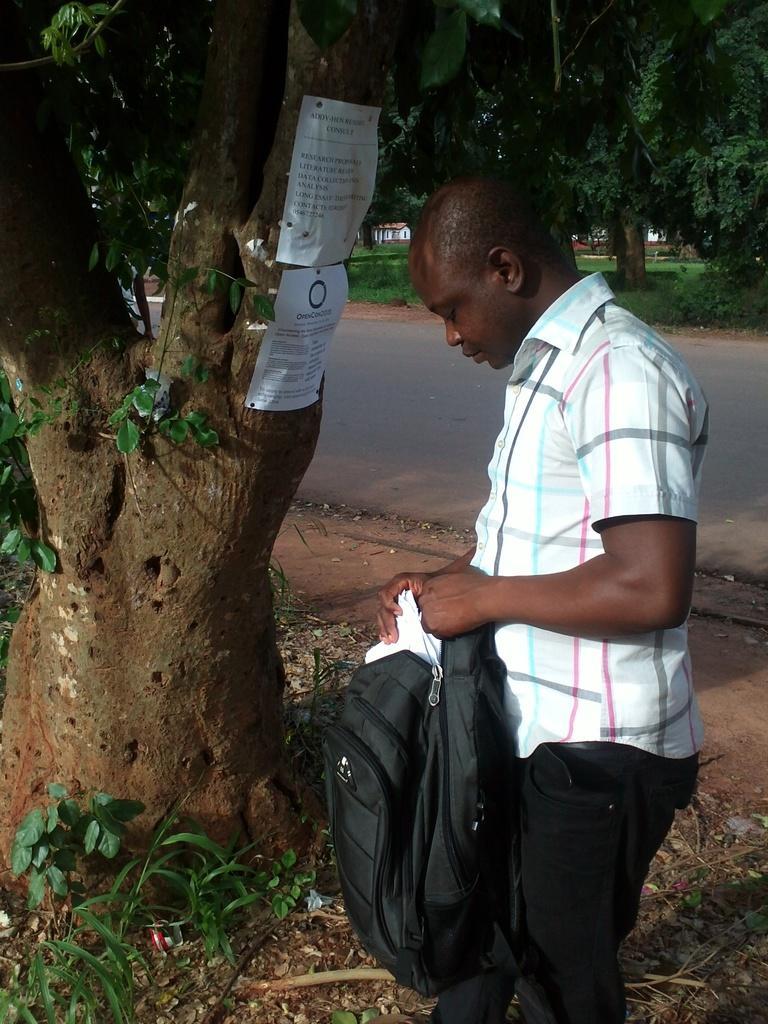Could you give a brief overview of what you see in this image? In this image I can see a man is standing holding a bag. I can also see a tree and two papers on it. 